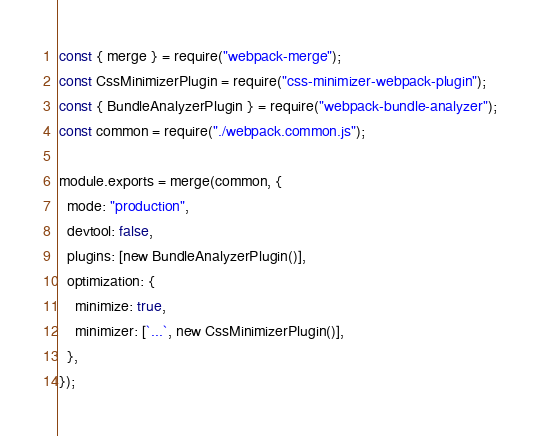Convert code to text. <code><loc_0><loc_0><loc_500><loc_500><_JavaScript_>const { merge } = require("webpack-merge");
const CssMinimizerPlugin = require("css-minimizer-webpack-plugin");
const { BundleAnalyzerPlugin } = require("webpack-bundle-analyzer");
const common = require("./webpack.common.js");

module.exports = merge(common, {
  mode: "production",
  devtool: false,
  plugins: [new BundleAnalyzerPlugin()],
  optimization: {
    minimize: true,
    minimizer: [`...`, new CssMinimizerPlugin()],
  },
});
</code> 